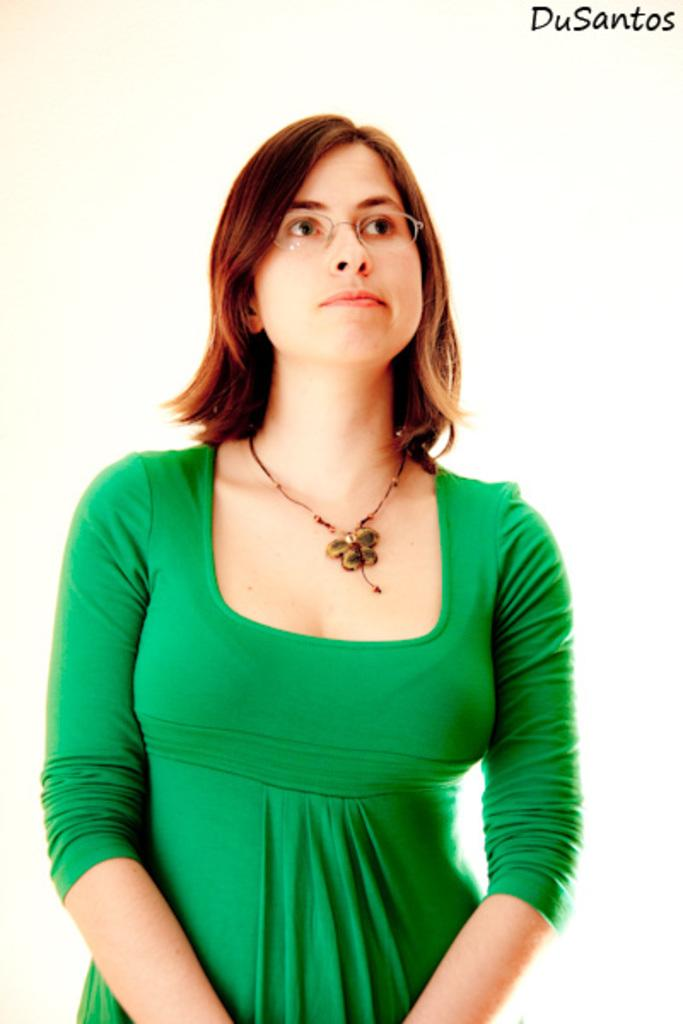What is the main subject of the image? There is a person standing in the image. What is the person wearing? The person is wearing a green dress. What color is the background of the image? The background of the image is white. How many gold coins can be seen on the hill in the image? There is no hill or gold coins present in the image; it features a person standing against a white background. 